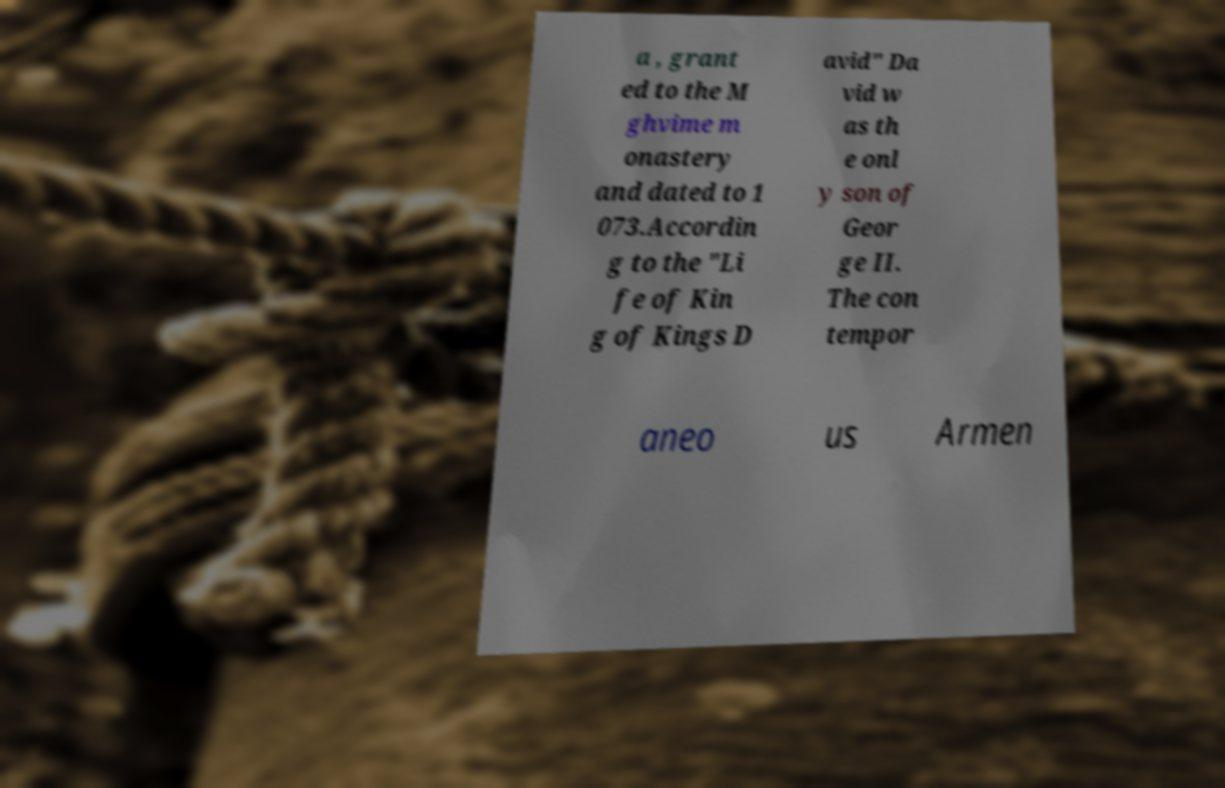I need the written content from this picture converted into text. Can you do that? a , grant ed to the M ghvime m onastery and dated to 1 073.Accordin g to the "Li fe of Kin g of Kings D avid" Da vid w as th e onl y son of Geor ge II. The con tempor aneo us Armen 